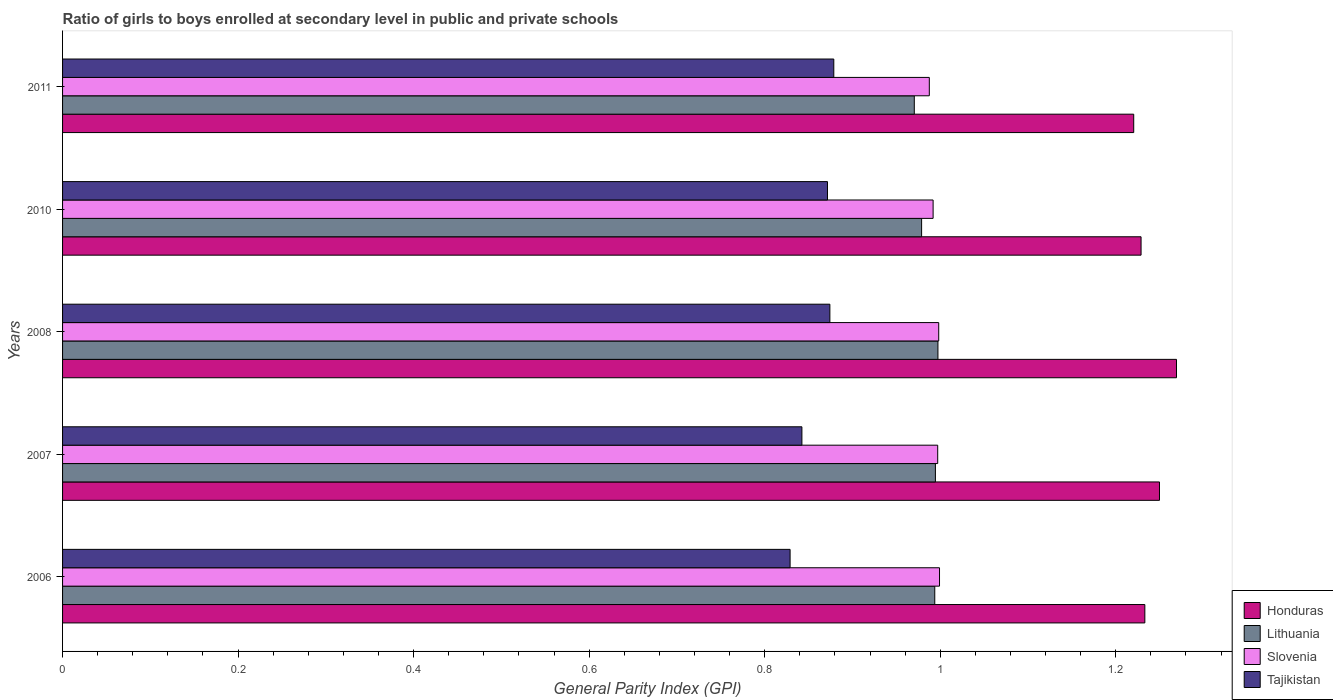How many groups of bars are there?
Your response must be concise. 5. Are the number of bars per tick equal to the number of legend labels?
Keep it short and to the point. Yes. Are the number of bars on each tick of the Y-axis equal?
Your answer should be very brief. Yes. How many bars are there on the 3rd tick from the top?
Keep it short and to the point. 4. How many bars are there on the 2nd tick from the bottom?
Keep it short and to the point. 4. In how many cases, is the number of bars for a given year not equal to the number of legend labels?
Ensure brevity in your answer.  0. What is the general parity index in Honduras in 2006?
Keep it short and to the point. 1.23. Across all years, what is the maximum general parity index in Honduras?
Give a very brief answer. 1.27. Across all years, what is the minimum general parity index in Slovenia?
Your answer should be very brief. 0.99. In which year was the general parity index in Honduras maximum?
Provide a short and direct response. 2008. In which year was the general parity index in Tajikistan minimum?
Your answer should be very brief. 2006. What is the total general parity index in Lithuania in the graph?
Your answer should be very brief. 4.93. What is the difference between the general parity index in Lithuania in 2006 and that in 2008?
Your response must be concise. -0. What is the difference between the general parity index in Lithuania in 2008 and the general parity index in Honduras in 2007?
Provide a short and direct response. -0.25. What is the average general parity index in Slovenia per year?
Provide a succinct answer. 0.99. In the year 2006, what is the difference between the general parity index in Honduras and general parity index in Lithuania?
Give a very brief answer. 0.24. What is the ratio of the general parity index in Lithuania in 2006 to that in 2007?
Your answer should be very brief. 1. Is the general parity index in Tajikistan in 2006 less than that in 2007?
Ensure brevity in your answer.  Yes. What is the difference between the highest and the second highest general parity index in Lithuania?
Give a very brief answer. 0. What is the difference between the highest and the lowest general parity index in Tajikistan?
Your response must be concise. 0.05. In how many years, is the general parity index in Slovenia greater than the average general parity index in Slovenia taken over all years?
Your answer should be compact. 3. What does the 1st bar from the top in 2007 represents?
Give a very brief answer. Tajikistan. What does the 2nd bar from the bottom in 2007 represents?
Give a very brief answer. Lithuania. How many bars are there?
Keep it short and to the point. 20. Are all the bars in the graph horizontal?
Provide a succinct answer. Yes. Does the graph contain grids?
Offer a very short reply. No. Where does the legend appear in the graph?
Offer a very short reply. Bottom right. How are the legend labels stacked?
Your response must be concise. Vertical. What is the title of the graph?
Make the answer very short. Ratio of girls to boys enrolled at secondary level in public and private schools. Does "Belize" appear as one of the legend labels in the graph?
Your response must be concise. No. What is the label or title of the X-axis?
Your answer should be compact. General Parity Index (GPI). What is the label or title of the Y-axis?
Your answer should be compact. Years. What is the General Parity Index (GPI) of Honduras in 2006?
Your answer should be very brief. 1.23. What is the General Parity Index (GPI) of Lithuania in 2006?
Make the answer very short. 0.99. What is the General Parity Index (GPI) in Slovenia in 2006?
Provide a succinct answer. 1. What is the General Parity Index (GPI) in Tajikistan in 2006?
Your response must be concise. 0.83. What is the General Parity Index (GPI) in Honduras in 2007?
Provide a short and direct response. 1.25. What is the General Parity Index (GPI) of Lithuania in 2007?
Give a very brief answer. 0.99. What is the General Parity Index (GPI) of Slovenia in 2007?
Your answer should be compact. 1. What is the General Parity Index (GPI) in Tajikistan in 2007?
Make the answer very short. 0.84. What is the General Parity Index (GPI) of Honduras in 2008?
Ensure brevity in your answer.  1.27. What is the General Parity Index (GPI) of Lithuania in 2008?
Provide a succinct answer. 1. What is the General Parity Index (GPI) of Slovenia in 2008?
Offer a very short reply. 1. What is the General Parity Index (GPI) of Tajikistan in 2008?
Keep it short and to the point. 0.87. What is the General Parity Index (GPI) in Honduras in 2010?
Provide a succinct answer. 1.23. What is the General Parity Index (GPI) of Lithuania in 2010?
Make the answer very short. 0.98. What is the General Parity Index (GPI) of Slovenia in 2010?
Offer a terse response. 0.99. What is the General Parity Index (GPI) in Tajikistan in 2010?
Offer a very short reply. 0.87. What is the General Parity Index (GPI) of Honduras in 2011?
Keep it short and to the point. 1.22. What is the General Parity Index (GPI) of Lithuania in 2011?
Your answer should be compact. 0.97. What is the General Parity Index (GPI) in Slovenia in 2011?
Give a very brief answer. 0.99. What is the General Parity Index (GPI) of Tajikistan in 2011?
Provide a short and direct response. 0.88. Across all years, what is the maximum General Parity Index (GPI) in Honduras?
Ensure brevity in your answer.  1.27. Across all years, what is the maximum General Parity Index (GPI) of Lithuania?
Your answer should be compact. 1. Across all years, what is the maximum General Parity Index (GPI) of Slovenia?
Provide a short and direct response. 1. Across all years, what is the maximum General Parity Index (GPI) of Tajikistan?
Ensure brevity in your answer.  0.88. Across all years, what is the minimum General Parity Index (GPI) in Honduras?
Your answer should be very brief. 1.22. Across all years, what is the minimum General Parity Index (GPI) of Lithuania?
Keep it short and to the point. 0.97. Across all years, what is the minimum General Parity Index (GPI) in Slovenia?
Your response must be concise. 0.99. Across all years, what is the minimum General Parity Index (GPI) in Tajikistan?
Make the answer very short. 0.83. What is the total General Parity Index (GPI) in Honduras in the graph?
Your answer should be compact. 6.2. What is the total General Parity Index (GPI) of Lithuania in the graph?
Provide a succinct answer. 4.93. What is the total General Parity Index (GPI) in Slovenia in the graph?
Offer a terse response. 4.97. What is the total General Parity Index (GPI) of Tajikistan in the graph?
Make the answer very short. 4.3. What is the difference between the General Parity Index (GPI) of Honduras in 2006 and that in 2007?
Make the answer very short. -0.02. What is the difference between the General Parity Index (GPI) of Lithuania in 2006 and that in 2007?
Offer a very short reply. -0. What is the difference between the General Parity Index (GPI) in Slovenia in 2006 and that in 2007?
Provide a short and direct response. 0. What is the difference between the General Parity Index (GPI) of Tajikistan in 2006 and that in 2007?
Provide a short and direct response. -0.01. What is the difference between the General Parity Index (GPI) in Honduras in 2006 and that in 2008?
Keep it short and to the point. -0.04. What is the difference between the General Parity Index (GPI) in Lithuania in 2006 and that in 2008?
Give a very brief answer. -0. What is the difference between the General Parity Index (GPI) in Slovenia in 2006 and that in 2008?
Make the answer very short. 0. What is the difference between the General Parity Index (GPI) of Tajikistan in 2006 and that in 2008?
Provide a short and direct response. -0.05. What is the difference between the General Parity Index (GPI) in Honduras in 2006 and that in 2010?
Give a very brief answer. 0. What is the difference between the General Parity Index (GPI) in Lithuania in 2006 and that in 2010?
Keep it short and to the point. 0.01. What is the difference between the General Parity Index (GPI) in Slovenia in 2006 and that in 2010?
Offer a very short reply. 0.01. What is the difference between the General Parity Index (GPI) in Tajikistan in 2006 and that in 2010?
Offer a terse response. -0.04. What is the difference between the General Parity Index (GPI) of Honduras in 2006 and that in 2011?
Keep it short and to the point. 0.01. What is the difference between the General Parity Index (GPI) in Lithuania in 2006 and that in 2011?
Your answer should be very brief. 0.02. What is the difference between the General Parity Index (GPI) in Slovenia in 2006 and that in 2011?
Your answer should be very brief. 0.01. What is the difference between the General Parity Index (GPI) in Tajikistan in 2006 and that in 2011?
Offer a terse response. -0.05. What is the difference between the General Parity Index (GPI) of Honduras in 2007 and that in 2008?
Provide a succinct answer. -0.02. What is the difference between the General Parity Index (GPI) of Lithuania in 2007 and that in 2008?
Your answer should be very brief. -0. What is the difference between the General Parity Index (GPI) of Slovenia in 2007 and that in 2008?
Offer a very short reply. -0. What is the difference between the General Parity Index (GPI) of Tajikistan in 2007 and that in 2008?
Provide a short and direct response. -0.03. What is the difference between the General Parity Index (GPI) in Honduras in 2007 and that in 2010?
Give a very brief answer. 0.02. What is the difference between the General Parity Index (GPI) of Lithuania in 2007 and that in 2010?
Give a very brief answer. 0.02. What is the difference between the General Parity Index (GPI) in Slovenia in 2007 and that in 2010?
Your answer should be compact. 0.01. What is the difference between the General Parity Index (GPI) in Tajikistan in 2007 and that in 2010?
Offer a very short reply. -0.03. What is the difference between the General Parity Index (GPI) of Honduras in 2007 and that in 2011?
Provide a short and direct response. 0.03. What is the difference between the General Parity Index (GPI) of Lithuania in 2007 and that in 2011?
Your answer should be compact. 0.02. What is the difference between the General Parity Index (GPI) of Slovenia in 2007 and that in 2011?
Provide a short and direct response. 0.01. What is the difference between the General Parity Index (GPI) of Tajikistan in 2007 and that in 2011?
Your answer should be very brief. -0.04. What is the difference between the General Parity Index (GPI) of Honduras in 2008 and that in 2010?
Your response must be concise. 0.04. What is the difference between the General Parity Index (GPI) in Lithuania in 2008 and that in 2010?
Your answer should be very brief. 0.02. What is the difference between the General Parity Index (GPI) of Slovenia in 2008 and that in 2010?
Keep it short and to the point. 0.01. What is the difference between the General Parity Index (GPI) in Tajikistan in 2008 and that in 2010?
Offer a terse response. 0. What is the difference between the General Parity Index (GPI) in Honduras in 2008 and that in 2011?
Your response must be concise. 0.05. What is the difference between the General Parity Index (GPI) of Lithuania in 2008 and that in 2011?
Make the answer very short. 0.03. What is the difference between the General Parity Index (GPI) of Slovenia in 2008 and that in 2011?
Give a very brief answer. 0.01. What is the difference between the General Parity Index (GPI) in Tajikistan in 2008 and that in 2011?
Keep it short and to the point. -0. What is the difference between the General Parity Index (GPI) of Honduras in 2010 and that in 2011?
Your answer should be very brief. 0.01. What is the difference between the General Parity Index (GPI) of Lithuania in 2010 and that in 2011?
Provide a short and direct response. 0.01. What is the difference between the General Parity Index (GPI) of Slovenia in 2010 and that in 2011?
Provide a succinct answer. 0. What is the difference between the General Parity Index (GPI) in Tajikistan in 2010 and that in 2011?
Keep it short and to the point. -0.01. What is the difference between the General Parity Index (GPI) in Honduras in 2006 and the General Parity Index (GPI) in Lithuania in 2007?
Your answer should be very brief. 0.24. What is the difference between the General Parity Index (GPI) in Honduras in 2006 and the General Parity Index (GPI) in Slovenia in 2007?
Offer a terse response. 0.24. What is the difference between the General Parity Index (GPI) in Honduras in 2006 and the General Parity Index (GPI) in Tajikistan in 2007?
Provide a succinct answer. 0.39. What is the difference between the General Parity Index (GPI) of Lithuania in 2006 and the General Parity Index (GPI) of Slovenia in 2007?
Keep it short and to the point. -0. What is the difference between the General Parity Index (GPI) in Lithuania in 2006 and the General Parity Index (GPI) in Tajikistan in 2007?
Ensure brevity in your answer.  0.15. What is the difference between the General Parity Index (GPI) of Slovenia in 2006 and the General Parity Index (GPI) of Tajikistan in 2007?
Make the answer very short. 0.16. What is the difference between the General Parity Index (GPI) of Honduras in 2006 and the General Parity Index (GPI) of Lithuania in 2008?
Offer a very short reply. 0.24. What is the difference between the General Parity Index (GPI) of Honduras in 2006 and the General Parity Index (GPI) of Slovenia in 2008?
Your answer should be very brief. 0.23. What is the difference between the General Parity Index (GPI) of Honduras in 2006 and the General Parity Index (GPI) of Tajikistan in 2008?
Ensure brevity in your answer.  0.36. What is the difference between the General Parity Index (GPI) in Lithuania in 2006 and the General Parity Index (GPI) in Slovenia in 2008?
Provide a succinct answer. -0. What is the difference between the General Parity Index (GPI) in Lithuania in 2006 and the General Parity Index (GPI) in Tajikistan in 2008?
Offer a terse response. 0.12. What is the difference between the General Parity Index (GPI) in Slovenia in 2006 and the General Parity Index (GPI) in Tajikistan in 2008?
Offer a terse response. 0.12. What is the difference between the General Parity Index (GPI) in Honduras in 2006 and the General Parity Index (GPI) in Lithuania in 2010?
Keep it short and to the point. 0.25. What is the difference between the General Parity Index (GPI) of Honduras in 2006 and the General Parity Index (GPI) of Slovenia in 2010?
Your answer should be very brief. 0.24. What is the difference between the General Parity Index (GPI) in Honduras in 2006 and the General Parity Index (GPI) in Tajikistan in 2010?
Your answer should be compact. 0.36. What is the difference between the General Parity Index (GPI) of Lithuania in 2006 and the General Parity Index (GPI) of Slovenia in 2010?
Offer a terse response. 0. What is the difference between the General Parity Index (GPI) in Lithuania in 2006 and the General Parity Index (GPI) in Tajikistan in 2010?
Provide a short and direct response. 0.12. What is the difference between the General Parity Index (GPI) in Slovenia in 2006 and the General Parity Index (GPI) in Tajikistan in 2010?
Your answer should be very brief. 0.13. What is the difference between the General Parity Index (GPI) in Honduras in 2006 and the General Parity Index (GPI) in Lithuania in 2011?
Provide a short and direct response. 0.26. What is the difference between the General Parity Index (GPI) of Honduras in 2006 and the General Parity Index (GPI) of Slovenia in 2011?
Your answer should be very brief. 0.25. What is the difference between the General Parity Index (GPI) in Honduras in 2006 and the General Parity Index (GPI) in Tajikistan in 2011?
Your response must be concise. 0.35. What is the difference between the General Parity Index (GPI) in Lithuania in 2006 and the General Parity Index (GPI) in Slovenia in 2011?
Provide a short and direct response. 0.01. What is the difference between the General Parity Index (GPI) in Lithuania in 2006 and the General Parity Index (GPI) in Tajikistan in 2011?
Keep it short and to the point. 0.12. What is the difference between the General Parity Index (GPI) of Slovenia in 2006 and the General Parity Index (GPI) of Tajikistan in 2011?
Provide a succinct answer. 0.12. What is the difference between the General Parity Index (GPI) in Honduras in 2007 and the General Parity Index (GPI) in Lithuania in 2008?
Keep it short and to the point. 0.25. What is the difference between the General Parity Index (GPI) in Honduras in 2007 and the General Parity Index (GPI) in Slovenia in 2008?
Offer a very short reply. 0.25. What is the difference between the General Parity Index (GPI) in Honduras in 2007 and the General Parity Index (GPI) in Tajikistan in 2008?
Offer a very short reply. 0.38. What is the difference between the General Parity Index (GPI) of Lithuania in 2007 and the General Parity Index (GPI) of Slovenia in 2008?
Your response must be concise. -0. What is the difference between the General Parity Index (GPI) in Lithuania in 2007 and the General Parity Index (GPI) in Tajikistan in 2008?
Your answer should be very brief. 0.12. What is the difference between the General Parity Index (GPI) of Slovenia in 2007 and the General Parity Index (GPI) of Tajikistan in 2008?
Provide a succinct answer. 0.12. What is the difference between the General Parity Index (GPI) in Honduras in 2007 and the General Parity Index (GPI) in Lithuania in 2010?
Offer a terse response. 0.27. What is the difference between the General Parity Index (GPI) in Honduras in 2007 and the General Parity Index (GPI) in Slovenia in 2010?
Your response must be concise. 0.26. What is the difference between the General Parity Index (GPI) in Honduras in 2007 and the General Parity Index (GPI) in Tajikistan in 2010?
Provide a succinct answer. 0.38. What is the difference between the General Parity Index (GPI) in Lithuania in 2007 and the General Parity Index (GPI) in Slovenia in 2010?
Provide a short and direct response. 0. What is the difference between the General Parity Index (GPI) in Lithuania in 2007 and the General Parity Index (GPI) in Tajikistan in 2010?
Your answer should be compact. 0.12. What is the difference between the General Parity Index (GPI) in Slovenia in 2007 and the General Parity Index (GPI) in Tajikistan in 2010?
Offer a terse response. 0.13. What is the difference between the General Parity Index (GPI) in Honduras in 2007 and the General Parity Index (GPI) in Lithuania in 2011?
Offer a very short reply. 0.28. What is the difference between the General Parity Index (GPI) of Honduras in 2007 and the General Parity Index (GPI) of Slovenia in 2011?
Offer a terse response. 0.26. What is the difference between the General Parity Index (GPI) of Honduras in 2007 and the General Parity Index (GPI) of Tajikistan in 2011?
Your answer should be compact. 0.37. What is the difference between the General Parity Index (GPI) in Lithuania in 2007 and the General Parity Index (GPI) in Slovenia in 2011?
Provide a short and direct response. 0.01. What is the difference between the General Parity Index (GPI) in Lithuania in 2007 and the General Parity Index (GPI) in Tajikistan in 2011?
Provide a succinct answer. 0.12. What is the difference between the General Parity Index (GPI) in Slovenia in 2007 and the General Parity Index (GPI) in Tajikistan in 2011?
Ensure brevity in your answer.  0.12. What is the difference between the General Parity Index (GPI) of Honduras in 2008 and the General Parity Index (GPI) of Lithuania in 2010?
Provide a short and direct response. 0.29. What is the difference between the General Parity Index (GPI) in Honduras in 2008 and the General Parity Index (GPI) in Slovenia in 2010?
Keep it short and to the point. 0.28. What is the difference between the General Parity Index (GPI) of Honduras in 2008 and the General Parity Index (GPI) of Tajikistan in 2010?
Ensure brevity in your answer.  0.4. What is the difference between the General Parity Index (GPI) in Lithuania in 2008 and the General Parity Index (GPI) in Slovenia in 2010?
Offer a very short reply. 0.01. What is the difference between the General Parity Index (GPI) of Lithuania in 2008 and the General Parity Index (GPI) of Tajikistan in 2010?
Make the answer very short. 0.13. What is the difference between the General Parity Index (GPI) of Slovenia in 2008 and the General Parity Index (GPI) of Tajikistan in 2010?
Make the answer very short. 0.13. What is the difference between the General Parity Index (GPI) of Honduras in 2008 and the General Parity Index (GPI) of Lithuania in 2011?
Offer a terse response. 0.3. What is the difference between the General Parity Index (GPI) of Honduras in 2008 and the General Parity Index (GPI) of Slovenia in 2011?
Your response must be concise. 0.28. What is the difference between the General Parity Index (GPI) in Honduras in 2008 and the General Parity Index (GPI) in Tajikistan in 2011?
Ensure brevity in your answer.  0.39. What is the difference between the General Parity Index (GPI) in Lithuania in 2008 and the General Parity Index (GPI) in Slovenia in 2011?
Your response must be concise. 0.01. What is the difference between the General Parity Index (GPI) in Lithuania in 2008 and the General Parity Index (GPI) in Tajikistan in 2011?
Your response must be concise. 0.12. What is the difference between the General Parity Index (GPI) in Slovenia in 2008 and the General Parity Index (GPI) in Tajikistan in 2011?
Provide a succinct answer. 0.12. What is the difference between the General Parity Index (GPI) in Honduras in 2010 and the General Parity Index (GPI) in Lithuania in 2011?
Your response must be concise. 0.26. What is the difference between the General Parity Index (GPI) in Honduras in 2010 and the General Parity Index (GPI) in Slovenia in 2011?
Make the answer very short. 0.24. What is the difference between the General Parity Index (GPI) in Honduras in 2010 and the General Parity Index (GPI) in Tajikistan in 2011?
Provide a succinct answer. 0.35. What is the difference between the General Parity Index (GPI) in Lithuania in 2010 and the General Parity Index (GPI) in Slovenia in 2011?
Make the answer very short. -0.01. What is the difference between the General Parity Index (GPI) of Slovenia in 2010 and the General Parity Index (GPI) of Tajikistan in 2011?
Provide a succinct answer. 0.11. What is the average General Parity Index (GPI) in Honduras per year?
Provide a short and direct response. 1.24. What is the average General Parity Index (GPI) in Lithuania per year?
Provide a short and direct response. 0.99. What is the average General Parity Index (GPI) of Slovenia per year?
Offer a very short reply. 0.99. What is the average General Parity Index (GPI) in Tajikistan per year?
Offer a terse response. 0.86. In the year 2006, what is the difference between the General Parity Index (GPI) of Honduras and General Parity Index (GPI) of Lithuania?
Offer a very short reply. 0.24. In the year 2006, what is the difference between the General Parity Index (GPI) of Honduras and General Parity Index (GPI) of Slovenia?
Your answer should be very brief. 0.23. In the year 2006, what is the difference between the General Parity Index (GPI) of Honduras and General Parity Index (GPI) of Tajikistan?
Your response must be concise. 0.4. In the year 2006, what is the difference between the General Parity Index (GPI) in Lithuania and General Parity Index (GPI) in Slovenia?
Offer a very short reply. -0.01. In the year 2006, what is the difference between the General Parity Index (GPI) in Lithuania and General Parity Index (GPI) in Tajikistan?
Make the answer very short. 0.16. In the year 2006, what is the difference between the General Parity Index (GPI) in Slovenia and General Parity Index (GPI) in Tajikistan?
Your response must be concise. 0.17. In the year 2007, what is the difference between the General Parity Index (GPI) in Honduras and General Parity Index (GPI) in Lithuania?
Ensure brevity in your answer.  0.26. In the year 2007, what is the difference between the General Parity Index (GPI) in Honduras and General Parity Index (GPI) in Slovenia?
Offer a terse response. 0.25. In the year 2007, what is the difference between the General Parity Index (GPI) of Honduras and General Parity Index (GPI) of Tajikistan?
Your answer should be very brief. 0.41. In the year 2007, what is the difference between the General Parity Index (GPI) of Lithuania and General Parity Index (GPI) of Slovenia?
Keep it short and to the point. -0. In the year 2007, what is the difference between the General Parity Index (GPI) in Lithuania and General Parity Index (GPI) in Tajikistan?
Offer a terse response. 0.15. In the year 2007, what is the difference between the General Parity Index (GPI) of Slovenia and General Parity Index (GPI) of Tajikistan?
Ensure brevity in your answer.  0.15. In the year 2008, what is the difference between the General Parity Index (GPI) in Honduras and General Parity Index (GPI) in Lithuania?
Your answer should be compact. 0.27. In the year 2008, what is the difference between the General Parity Index (GPI) in Honduras and General Parity Index (GPI) in Slovenia?
Keep it short and to the point. 0.27. In the year 2008, what is the difference between the General Parity Index (GPI) of Honduras and General Parity Index (GPI) of Tajikistan?
Your answer should be compact. 0.39. In the year 2008, what is the difference between the General Parity Index (GPI) of Lithuania and General Parity Index (GPI) of Slovenia?
Your response must be concise. -0. In the year 2008, what is the difference between the General Parity Index (GPI) of Lithuania and General Parity Index (GPI) of Tajikistan?
Provide a short and direct response. 0.12. In the year 2008, what is the difference between the General Parity Index (GPI) of Slovenia and General Parity Index (GPI) of Tajikistan?
Give a very brief answer. 0.12. In the year 2010, what is the difference between the General Parity Index (GPI) in Honduras and General Parity Index (GPI) in Lithuania?
Keep it short and to the point. 0.25. In the year 2010, what is the difference between the General Parity Index (GPI) of Honduras and General Parity Index (GPI) of Slovenia?
Keep it short and to the point. 0.24. In the year 2010, what is the difference between the General Parity Index (GPI) of Honduras and General Parity Index (GPI) of Tajikistan?
Your response must be concise. 0.36. In the year 2010, what is the difference between the General Parity Index (GPI) of Lithuania and General Parity Index (GPI) of Slovenia?
Offer a terse response. -0.01. In the year 2010, what is the difference between the General Parity Index (GPI) of Lithuania and General Parity Index (GPI) of Tajikistan?
Your answer should be compact. 0.11. In the year 2010, what is the difference between the General Parity Index (GPI) of Slovenia and General Parity Index (GPI) of Tajikistan?
Your answer should be very brief. 0.12. In the year 2011, what is the difference between the General Parity Index (GPI) of Honduras and General Parity Index (GPI) of Lithuania?
Offer a very short reply. 0.25. In the year 2011, what is the difference between the General Parity Index (GPI) in Honduras and General Parity Index (GPI) in Slovenia?
Ensure brevity in your answer.  0.23. In the year 2011, what is the difference between the General Parity Index (GPI) of Honduras and General Parity Index (GPI) of Tajikistan?
Your answer should be compact. 0.34. In the year 2011, what is the difference between the General Parity Index (GPI) in Lithuania and General Parity Index (GPI) in Slovenia?
Provide a succinct answer. -0.02. In the year 2011, what is the difference between the General Parity Index (GPI) in Lithuania and General Parity Index (GPI) in Tajikistan?
Your answer should be very brief. 0.09. In the year 2011, what is the difference between the General Parity Index (GPI) in Slovenia and General Parity Index (GPI) in Tajikistan?
Offer a terse response. 0.11. What is the ratio of the General Parity Index (GPI) of Honduras in 2006 to that in 2007?
Ensure brevity in your answer.  0.99. What is the ratio of the General Parity Index (GPI) in Lithuania in 2006 to that in 2007?
Your answer should be very brief. 1. What is the ratio of the General Parity Index (GPI) in Slovenia in 2006 to that in 2007?
Make the answer very short. 1. What is the ratio of the General Parity Index (GPI) in Tajikistan in 2006 to that in 2007?
Give a very brief answer. 0.98. What is the ratio of the General Parity Index (GPI) in Honduras in 2006 to that in 2008?
Your answer should be compact. 0.97. What is the ratio of the General Parity Index (GPI) in Lithuania in 2006 to that in 2008?
Your response must be concise. 1. What is the ratio of the General Parity Index (GPI) in Slovenia in 2006 to that in 2008?
Provide a succinct answer. 1. What is the ratio of the General Parity Index (GPI) of Tajikistan in 2006 to that in 2008?
Provide a short and direct response. 0.95. What is the ratio of the General Parity Index (GPI) of Lithuania in 2006 to that in 2010?
Keep it short and to the point. 1.02. What is the ratio of the General Parity Index (GPI) of Slovenia in 2006 to that in 2010?
Your answer should be compact. 1.01. What is the ratio of the General Parity Index (GPI) of Tajikistan in 2006 to that in 2010?
Provide a succinct answer. 0.95. What is the ratio of the General Parity Index (GPI) in Honduras in 2006 to that in 2011?
Offer a terse response. 1.01. What is the ratio of the General Parity Index (GPI) of Lithuania in 2006 to that in 2011?
Your answer should be very brief. 1.02. What is the ratio of the General Parity Index (GPI) in Slovenia in 2006 to that in 2011?
Give a very brief answer. 1.01. What is the ratio of the General Parity Index (GPI) of Tajikistan in 2006 to that in 2011?
Give a very brief answer. 0.94. What is the ratio of the General Parity Index (GPI) of Honduras in 2007 to that in 2008?
Make the answer very short. 0.98. What is the ratio of the General Parity Index (GPI) in Slovenia in 2007 to that in 2008?
Keep it short and to the point. 1. What is the ratio of the General Parity Index (GPI) of Tajikistan in 2007 to that in 2008?
Provide a short and direct response. 0.96. What is the ratio of the General Parity Index (GPI) in Honduras in 2007 to that in 2010?
Give a very brief answer. 1.02. What is the ratio of the General Parity Index (GPI) in Lithuania in 2007 to that in 2010?
Offer a terse response. 1.02. What is the ratio of the General Parity Index (GPI) in Tajikistan in 2007 to that in 2010?
Give a very brief answer. 0.97. What is the ratio of the General Parity Index (GPI) in Honduras in 2007 to that in 2011?
Offer a terse response. 1.02. What is the ratio of the General Parity Index (GPI) in Lithuania in 2007 to that in 2011?
Your response must be concise. 1.02. What is the ratio of the General Parity Index (GPI) of Slovenia in 2007 to that in 2011?
Give a very brief answer. 1.01. What is the ratio of the General Parity Index (GPI) in Tajikistan in 2007 to that in 2011?
Make the answer very short. 0.96. What is the ratio of the General Parity Index (GPI) of Honduras in 2008 to that in 2010?
Give a very brief answer. 1.03. What is the ratio of the General Parity Index (GPI) of Lithuania in 2008 to that in 2010?
Offer a very short reply. 1.02. What is the ratio of the General Parity Index (GPI) of Slovenia in 2008 to that in 2010?
Your answer should be compact. 1.01. What is the ratio of the General Parity Index (GPI) in Tajikistan in 2008 to that in 2010?
Provide a short and direct response. 1. What is the ratio of the General Parity Index (GPI) of Honduras in 2008 to that in 2011?
Make the answer very short. 1.04. What is the ratio of the General Parity Index (GPI) of Lithuania in 2008 to that in 2011?
Give a very brief answer. 1.03. What is the ratio of the General Parity Index (GPI) of Slovenia in 2008 to that in 2011?
Give a very brief answer. 1.01. What is the ratio of the General Parity Index (GPI) in Tajikistan in 2008 to that in 2011?
Keep it short and to the point. 0.99. What is the ratio of the General Parity Index (GPI) of Honduras in 2010 to that in 2011?
Provide a succinct answer. 1.01. What is the ratio of the General Parity Index (GPI) in Lithuania in 2010 to that in 2011?
Make the answer very short. 1.01. What is the ratio of the General Parity Index (GPI) in Tajikistan in 2010 to that in 2011?
Ensure brevity in your answer.  0.99. What is the difference between the highest and the second highest General Parity Index (GPI) in Honduras?
Your answer should be compact. 0.02. What is the difference between the highest and the second highest General Parity Index (GPI) of Lithuania?
Your response must be concise. 0. What is the difference between the highest and the second highest General Parity Index (GPI) in Slovenia?
Your answer should be compact. 0. What is the difference between the highest and the second highest General Parity Index (GPI) of Tajikistan?
Offer a very short reply. 0. What is the difference between the highest and the lowest General Parity Index (GPI) of Honduras?
Provide a succinct answer. 0.05. What is the difference between the highest and the lowest General Parity Index (GPI) of Lithuania?
Offer a very short reply. 0.03. What is the difference between the highest and the lowest General Parity Index (GPI) in Slovenia?
Provide a succinct answer. 0.01. What is the difference between the highest and the lowest General Parity Index (GPI) of Tajikistan?
Keep it short and to the point. 0.05. 